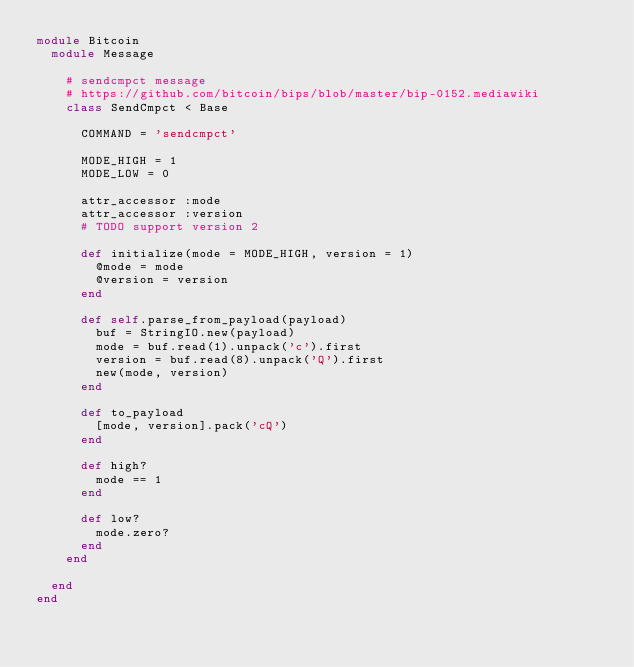Convert code to text. <code><loc_0><loc_0><loc_500><loc_500><_Ruby_>module Bitcoin
  module Message

    # sendcmpct message
    # https://github.com/bitcoin/bips/blob/master/bip-0152.mediawiki
    class SendCmpct < Base

      COMMAND = 'sendcmpct'

      MODE_HIGH = 1
      MODE_LOW = 0

      attr_accessor :mode
      attr_accessor :version
      # TODO support version 2

      def initialize(mode = MODE_HIGH, version = 1)
        @mode = mode
        @version = version
      end

      def self.parse_from_payload(payload)
        buf = StringIO.new(payload)
        mode = buf.read(1).unpack('c').first
        version = buf.read(8).unpack('Q').first
        new(mode, version)
      end

      def to_payload
        [mode, version].pack('cQ')
      end

      def high?
        mode == 1
      end

      def low?
        mode.zero?
      end
    end

  end
end
</code> 